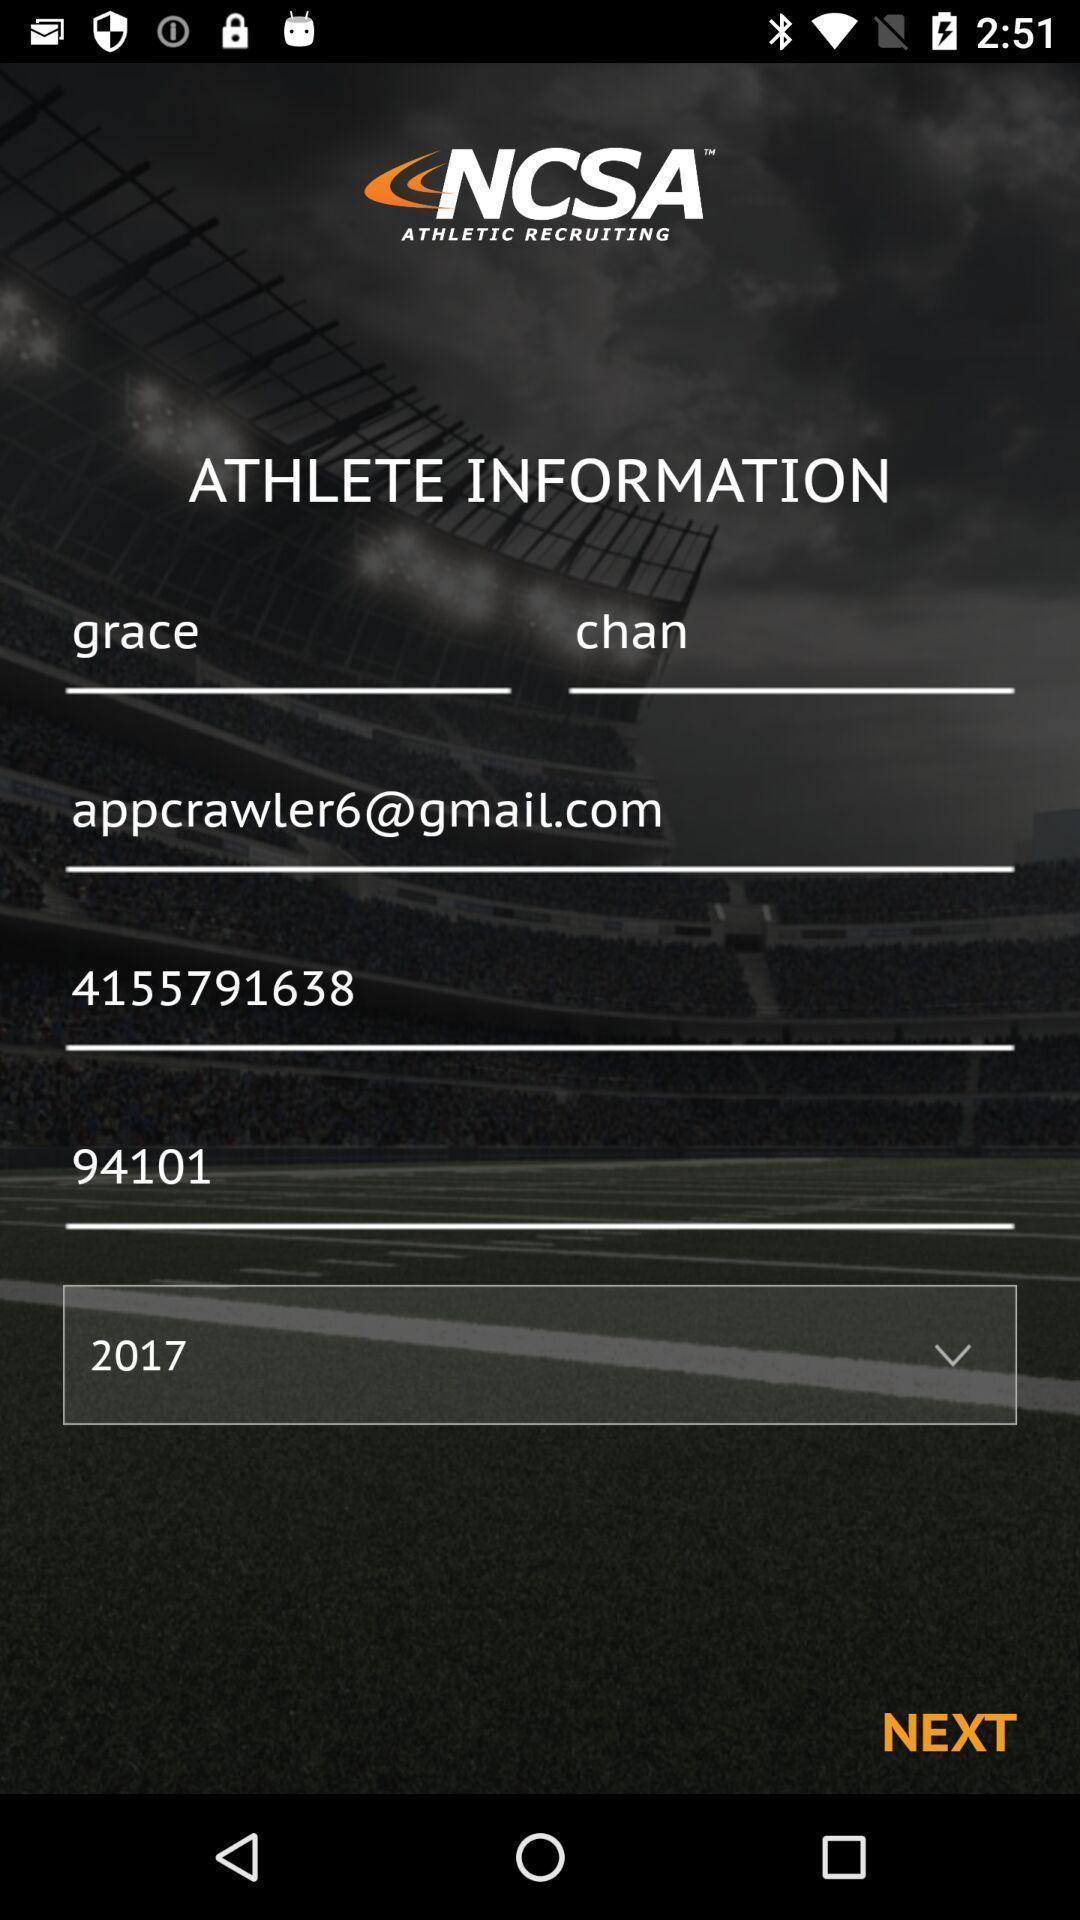Provide a description of this screenshot. Page showing options to enter athlete information in sports app. 